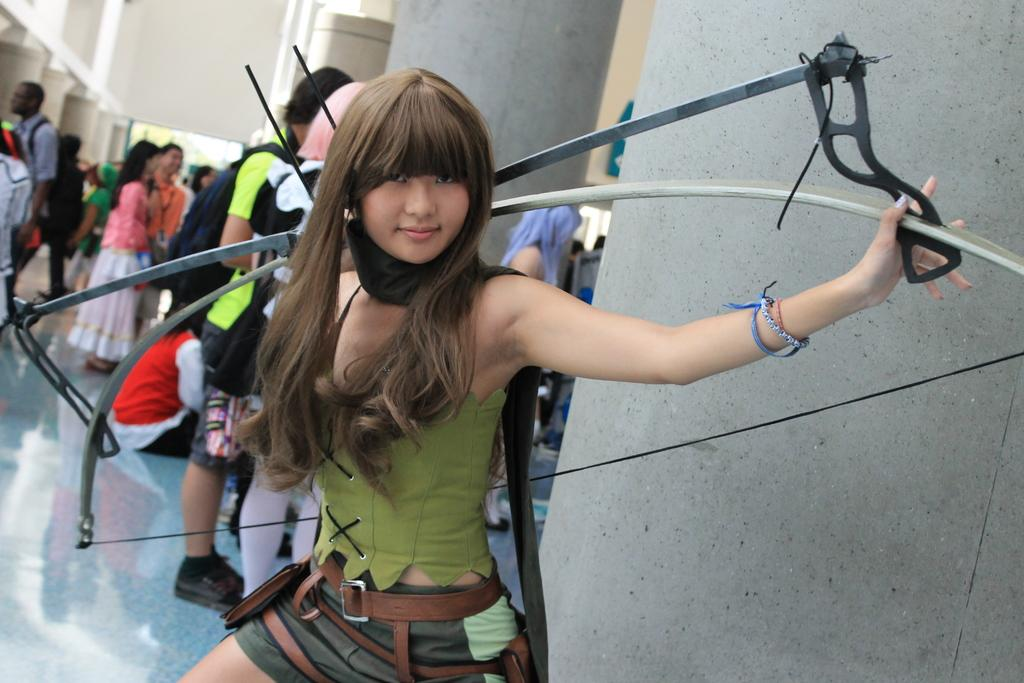Who is the main subject in the image? There is a woman in the image. What is the woman holding in the image? The woman is holding a bow. What can be seen in the background of the image? There are men and women standing in the background of the image. How does the woman's aunt feel about her holding the bow in the image? There is no information about the woman's aunt in the image, so it cannot be determined how she feels about the woman holding the bow. 